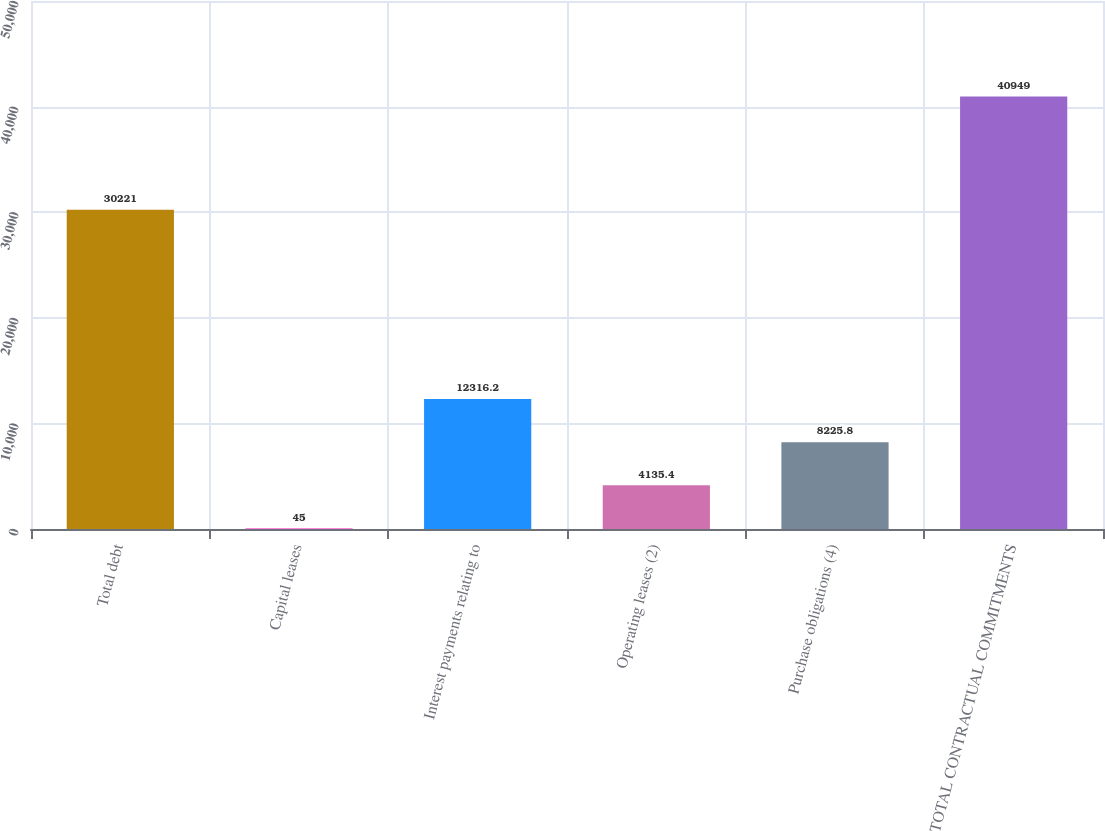<chart> <loc_0><loc_0><loc_500><loc_500><bar_chart><fcel>Total debt<fcel>Capital leases<fcel>Interest payments relating to<fcel>Operating leases (2)<fcel>Purchase obligations (4)<fcel>TOTAL CONTRACTUAL COMMITMENTS<nl><fcel>30221<fcel>45<fcel>12316.2<fcel>4135.4<fcel>8225.8<fcel>40949<nl></chart> 